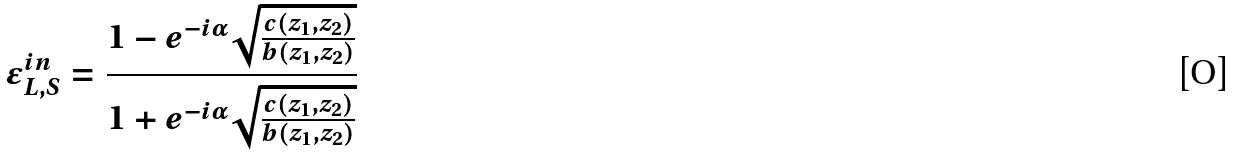Convert formula to latex. <formula><loc_0><loc_0><loc_500><loc_500>\epsilon _ { L , S } ^ { i n } = \frac { 1 - e ^ { - i \alpha } \sqrt { \frac { c ( z _ { 1 } , z _ { 2 } ) } { b ( z _ { 1 } , z _ { 2 } ) } } } { 1 + e ^ { - i \alpha } \sqrt { \frac { c ( z _ { 1 } , z _ { 2 } ) } { b ( z _ { 1 } , z _ { 2 } ) } } }</formula> 